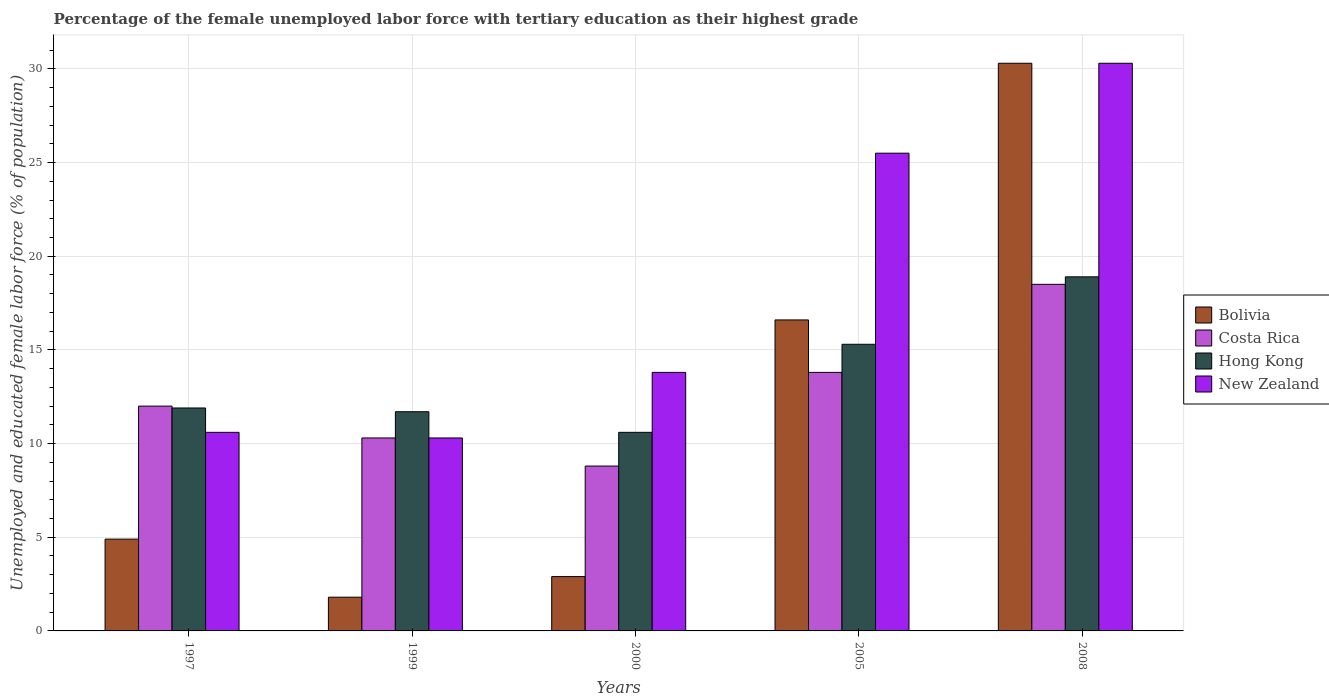How many different coloured bars are there?
Your answer should be very brief. 4. Are the number of bars on each tick of the X-axis equal?
Keep it short and to the point. Yes. How many bars are there on the 2nd tick from the left?
Your answer should be compact. 4. How many bars are there on the 2nd tick from the right?
Give a very brief answer. 4. In how many cases, is the number of bars for a given year not equal to the number of legend labels?
Offer a very short reply. 0. What is the percentage of the unemployed female labor force with tertiary education in New Zealand in 2000?
Your response must be concise. 13.8. Across all years, what is the maximum percentage of the unemployed female labor force with tertiary education in Costa Rica?
Your answer should be compact. 18.5. Across all years, what is the minimum percentage of the unemployed female labor force with tertiary education in Hong Kong?
Make the answer very short. 10.6. In which year was the percentage of the unemployed female labor force with tertiary education in New Zealand maximum?
Provide a short and direct response. 2008. In which year was the percentage of the unemployed female labor force with tertiary education in Bolivia minimum?
Give a very brief answer. 1999. What is the total percentage of the unemployed female labor force with tertiary education in Costa Rica in the graph?
Offer a very short reply. 63.4. What is the difference between the percentage of the unemployed female labor force with tertiary education in Hong Kong in 1999 and that in 2000?
Your answer should be compact. 1.1. What is the difference between the percentage of the unemployed female labor force with tertiary education in Bolivia in 2000 and the percentage of the unemployed female labor force with tertiary education in Hong Kong in 2005?
Ensure brevity in your answer.  -12.4. What is the average percentage of the unemployed female labor force with tertiary education in Costa Rica per year?
Your answer should be compact. 12.68. What is the ratio of the percentage of the unemployed female labor force with tertiary education in New Zealand in 1999 to that in 2008?
Offer a very short reply. 0.34. Is the percentage of the unemployed female labor force with tertiary education in Hong Kong in 1997 less than that in 2008?
Offer a very short reply. Yes. What is the difference between the highest and the second highest percentage of the unemployed female labor force with tertiary education in New Zealand?
Your response must be concise. 4.8. What is the difference between the highest and the lowest percentage of the unemployed female labor force with tertiary education in Hong Kong?
Offer a very short reply. 8.3. In how many years, is the percentage of the unemployed female labor force with tertiary education in Hong Kong greater than the average percentage of the unemployed female labor force with tertiary education in Hong Kong taken over all years?
Ensure brevity in your answer.  2. Is it the case that in every year, the sum of the percentage of the unemployed female labor force with tertiary education in Bolivia and percentage of the unemployed female labor force with tertiary education in Hong Kong is greater than the sum of percentage of the unemployed female labor force with tertiary education in Costa Rica and percentage of the unemployed female labor force with tertiary education in New Zealand?
Offer a very short reply. No. What does the 4th bar from the left in 2005 represents?
Offer a terse response. New Zealand. What does the 2nd bar from the right in 2005 represents?
Your answer should be compact. Hong Kong. Is it the case that in every year, the sum of the percentage of the unemployed female labor force with tertiary education in Costa Rica and percentage of the unemployed female labor force with tertiary education in Hong Kong is greater than the percentage of the unemployed female labor force with tertiary education in New Zealand?
Keep it short and to the point. Yes. Are all the bars in the graph horizontal?
Your answer should be compact. No. How many legend labels are there?
Give a very brief answer. 4. How are the legend labels stacked?
Offer a very short reply. Vertical. What is the title of the graph?
Offer a very short reply. Percentage of the female unemployed labor force with tertiary education as their highest grade. Does "Eritrea" appear as one of the legend labels in the graph?
Your answer should be very brief. No. What is the label or title of the X-axis?
Offer a terse response. Years. What is the label or title of the Y-axis?
Your answer should be compact. Unemployed and educated female labor force (% of population). What is the Unemployed and educated female labor force (% of population) in Bolivia in 1997?
Give a very brief answer. 4.9. What is the Unemployed and educated female labor force (% of population) in Hong Kong in 1997?
Your answer should be very brief. 11.9. What is the Unemployed and educated female labor force (% of population) of New Zealand in 1997?
Provide a short and direct response. 10.6. What is the Unemployed and educated female labor force (% of population) in Bolivia in 1999?
Keep it short and to the point. 1.8. What is the Unemployed and educated female labor force (% of population) in Costa Rica in 1999?
Offer a very short reply. 10.3. What is the Unemployed and educated female labor force (% of population) of Hong Kong in 1999?
Give a very brief answer. 11.7. What is the Unemployed and educated female labor force (% of population) of New Zealand in 1999?
Your answer should be very brief. 10.3. What is the Unemployed and educated female labor force (% of population) of Bolivia in 2000?
Make the answer very short. 2.9. What is the Unemployed and educated female labor force (% of population) in Costa Rica in 2000?
Ensure brevity in your answer.  8.8. What is the Unemployed and educated female labor force (% of population) of Hong Kong in 2000?
Provide a succinct answer. 10.6. What is the Unemployed and educated female labor force (% of population) of New Zealand in 2000?
Ensure brevity in your answer.  13.8. What is the Unemployed and educated female labor force (% of population) in Bolivia in 2005?
Give a very brief answer. 16.6. What is the Unemployed and educated female labor force (% of population) in Costa Rica in 2005?
Make the answer very short. 13.8. What is the Unemployed and educated female labor force (% of population) of Hong Kong in 2005?
Provide a succinct answer. 15.3. What is the Unemployed and educated female labor force (% of population) in New Zealand in 2005?
Provide a short and direct response. 25.5. What is the Unemployed and educated female labor force (% of population) in Bolivia in 2008?
Provide a short and direct response. 30.3. What is the Unemployed and educated female labor force (% of population) of Hong Kong in 2008?
Offer a terse response. 18.9. What is the Unemployed and educated female labor force (% of population) of New Zealand in 2008?
Make the answer very short. 30.3. Across all years, what is the maximum Unemployed and educated female labor force (% of population) in Bolivia?
Provide a short and direct response. 30.3. Across all years, what is the maximum Unemployed and educated female labor force (% of population) in Costa Rica?
Give a very brief answer. 18.5. Across all years, what is the maximum Unemployed and educated female labor force (% of population) in Hong Kong?
Make the answer very short. 18.9. Across all years, what is the maximum Unemployed and educated female labor force (% of population) of New Zealand?
Make the answer very short. 30.3. Across all years, what is the minimum Unemployed and educated female labor force (% of population) in Bolivia?
Provide a short and direct response. 1.8. Across all years, what is the minimum Unemployed and educated female labor force (% of population) of Costa Rica?
Provide a succinct answer. 8.8. Across all years, what is the minimum Unemployed and educated female labor force (% of population) of Hong Kong?
Give a very brief answer. 10.6. Across all years, what is the minimum Unemployed and educated female labor force (% of population) of New Zealand?
Provide a short and direct response. 10.3. What is the total Unemployed and educated female labor force (% of population) of Bolivia in the graph?
Make the answer very short. 56.5. What is the total Unemployed and educated female labor force (% of population) of Costa Rica in the graph?
Your response must be concise. 63.4. What is the total Unemployed and educated female labor force (% of population) in Hong Kong in the graph?
Your answer should be very brief. 68.4. What is the total Unemployed and educated female labor force (% of population) of New Zealand in the graph?
Offer a very short reply. 90.5. What is the difference between the Unemployed and educated female labor force (% of population) in Costa Rica in 1997 and that in 1999?
Make the answer very short. 1.7. What is the difference between the Unemployed and educated female labor force (% of population) in New Zealand in 1997 and that in 1999?
Keep it short and to the point. 0.3. What is the difference between the Unemployed and educated female labor force (% of population) of Bolivia in 1997 and that in 2000?
Your answer should be very brief. 2. What is the difference between the Unemployed and educated female labor force (% of population) of Costa Rica in 1997 and that in 2000?
Your response must be concise. 3.2. What is the difference between the Unemployed and educated female labor force (% of population) of New Zealand in 1997 and that in 2000?
Keep it short and to the point. -3.2. What is the difference between the Unemployed and educated female labor force (% of population) in New Zealand in 1997 and that in 2005?
Your response must be concise. -14.9. What is the difference between the Unemployed and educated female labor force (% of population) in Bolivia in 1997 and that in 2008?
Keep it short and to the point. -25.4. What is the difference between the Unemployed and educated female labor force (% of population) in Hong Kong in 1997 and that in 2008?
Offer a terse response. -7. What is the difference between the Unemployed and educated female labor force (% of population) in New Zealand in 1997 and that in 2008?
Your answer should be very brief. -19.7. What is the difference between the Unemployed and educated female labor force (% of population) of Bolivia in 1999 and that in 2000?
Offer a terse response. -1.1. What is the difference between the Unemployed and educated female labor force (% of population) in Costa Rica in 1999 and that in 2000?
Offer a very short reply. 1.5. What is the difference between the Unemployed and educated female labor force (% of population) in Hong Kong in 1999 and that in 2000?
Keep it short and to the point. 1.1. What is the difference between the Unemployed and educated female labor force (% of population) in New Zealand in 1999 and that in 2000?
Your answer should be compact. -3.5. What is the difference between the Unemployed and educated female labor force (% of population) of Bolivia in 1999 and that in 2005?
Your answer should be compact. -14.8. What is the difference between the Unemployed and educated female labor force (% of population) in Costa Rica in 1999 and that in 2005?
Offer a terse response. -3.5. What is the difference between the Unemployed and educated female labor force (% of population) in Hong Kong in 1999 and that in 2005?
Your answer should be very brief. -3.6. What is the difference between the Unemployed and educated female labor force (% of population) of New Zealand in 1999 and that in 2005?
Ensure brevity in your answer.  -15.2. What is the difference between the Unemployed and educated female labor force (% of population) in Bolivia in 1999 and that in 2008?
Provide a succinct answer. -28.5. What is the difference between the Unemployed and educated female labor force (% of population) of Costa Rica in 1999 and that in 2008?
Ensure brevity in your answer.  -8.2. What is the difference between the Unemployed and educated female labor force (% of population) in New Zealand in 1999 and that in 2008?
Offer a terse response. -20. What is the difference between the Unemployed and educated female labor force (% of population) of Bolivia in 2000 and that in 2005?
Give a very brief answer. -13.7. What is the difference between the Unemployed and educated female labor force (% of population) of Costa Rica in 2000 and that in 2005?
Provide a short and direct response. -5. What is the difference between the Unemployed and educated female labor force (% of population) in Bolivia in 2000 and that in 2008?
Your response must be concise. -27.4. What is the difference between the Unemployed and educated female labor force (% of population) of New Zealand in 2000 and that in 2008?
Give a very brief answer. -16.5. What is the difference between the Unemployed and educated female labor force (% of population) in Bolivia in 2005 and that in 2008?
Offer a very short reply. -13.7. What is the difference between the Unemployed and educated female labor force (% of population) in Bolivia in 1997 and the Unemployed and educated female labor force (% of population) in Costa Rica in 1999?
Offer a very short reply. -5.4. What is the difference between the Unemployed and educated female labor force (% of population) of Bolivia in 1997 and the Unemployed and educated female labor force (% of population) of Hong Kong in 1999?
Your answer should be very brief. -6.8. What is the difference between the Unemployed and educated female labor force (% of population) of Bolivia in 1997 and the Unemployed and educated female labor force (% of population) of New Zealand in 1999?
Offer a very short reply. -5.4. What is the difference between the Unemployed and educated female labor force (% of population) of Bolivia in 1997 and the Unemployed and educated female labor force (% of population) of New Zealand in 2000?
Offer a very short reply. -8.9. What is the difference between the Unemployed and educated female labor force (% of population) of Costa Rica in 1997 and the Unemployed and educated female labor force (% of population) of Hong Kong in 2000?
Offer a terse response. 1.4. What is the difference between the Unemployed and educated female labor force (% of population) of Hong Kong in 1997 and the Unemployed and educated female labor force (% of population) of New Zealand in 2000?
Ensure brevity in your answer.  -1.9. What is the difference between the Unemployed and educated female labor force (% of population) of Bolivia in 1997 and the Unemployed and educated female labor force (% of population) of Costa Rica in 2005?
Make the answer very short. -8.9. What is the difference between the Unemployed and educated female labor force (% of population) of Bolivia in 1997 and the Unemployed and educated female labor force (% of population) of Hong Kong in 2005?
Offer a terse response. -10.4. What is the difference between the Unemployed and educated female labor force (% of population) of Bolivia in 1997 and the Unemployed and educated female labor force (% of population) of New Zealand in 2005?
Give a very brief answer. -20.6. What is the difference between the Unemployed and educated female labor force (% of population) in Hong Kong in 1997 and the Unemployed and educated female labor force (% of population) in New Zealand in 2005?
Offer a very short reply. -13.6. What is the difference between the Unemployed and educated female labor force (% of population) of Bolivia in 1997 and the Unemployed and educated female labor force (% of population) of New Zealand in 2008?
Provide a succinct answer. -25.4. What is the difference between the Unemployed and educated female labor force (% of population) of Costa Rica in 1997 and the Unemployed and educated female labor force (% of population) of Hong Kong in 2008?
Offer a terse response. -6.9. What is the difference between the Unemployed and educated female labor force (% of population) of Costa Rica in 1997 and the Unemployed and educated female labor force (% of population) of New Zealand in 2008?
Provide a succinct answer. -18.3. What is the difference between the Unemployed and educated female labor force (% of population) in Hong Kong in 1997 and the Unemployed and educated female labor force (% of population) in New Zealand in 2008?
Your answer should be very brief. -18.4. What is the difference between the Unemployed and educated female labor force (% of population) in Bolivia in 1999 and the Unemployed and educated female labor force (% of population) in Costa Rica in 2000?
Offer a very short reply. -7. What is the difference between the Unemployed and educated female labor force (% of population) of Bolivia in 1999 and the Unemployed and educated female labor force (% of population) of Hong Kong in 2000?
Your answer should be compact. -8.8. What is the difference between the Unemployed and educated female labor force (% of population) of Costa Rica in 1999 and the Unemployed and educated female labor force (% of population) of Hong Kong in 2000?
Keep it short and to the point. -0.3. What is the difference between the Unemployed and educated female labor force (% of population) of Costa Rica in 1999 and the Unemployed and educated female labor force (% of population) of New Zealand in 2000?
Your answer should be very brief. -3.5. What is the difference between the Unemployed and educated female labor force (% of population) in Bolivia in 1999 and the Unemployed and educated female labor force (% of population) in Hong Kong in 2005?
Give a very brief answer. -13.5. What is the difference between the Unemployed and educated female labor force (% of population) of Bolivia in 1999 and the Unemployed and educated female labor force (% of population) of New Zealand in 2005?
Provide a short and direct response. -23.7. What is the difference between the Unemployed and educated female labor force (% of population) in Costa Rica in 1999 and the Unemployed and educated female labor force (% of population) in Hong Kong in 2005?
Your answer should be very brief. -5. What is the difference between the Unemployed and educated female labor force (% of population) in Costa Rica in 1999 and the Unemployed and educated female labor force (% of population) in New Zealand in 2005?
Provide a succinct answer. -15.2. What is the difference between the Unemployed and educated female labor force (% of population) of Bolivia in 1999 and the Unemployed and educated female labor force (% of population) of Costa Rica in 2008?
Make the answer very short. -16.7. What is the difference between the Unemployed and educated female labor force (% of population) in Bolivia in 1999 and the Unemployed and educated female labor force (% of population) in Hong Kong in 2008?
Your answer should be very brief. -17.1. What is the difference between the Unemployed and educated female labor force (% of population) of Bolivia in 1999 and the Unemployed and educated female labor force (% of population) of New Zealand in 2008?
Your answer should be compact. -28.5. What is the difference between the Unemployed and educated female labor force (% of population) in Costa Rica in 1999 and the Unemployed and educated female labor force (% of population) in Hong Kong in 2008?
Your answer should be compact. -8.6. What is the difference between the Unemployed and educated female labor force (% of population) in Hong Kong in 1999 and the Unemployed and educated female labor force (% of population) in New Zealand in 2008?
Your answer should be very brief. -18.6. What is the difference between the Unemployed and educated female labor force (% of population) in Bolivia in 2000 and the Unemployed and educated female labor force (% of population) in Costa Rica in 2005?
Offer a very short reply. -10.9. What is the difference between the Unemployed and educated female labor force (% of population) in Bolivia in 2000 and the Unemployed and educated female labor force (% of population) in Hong Kong in 2005?
Your answer should be compact. -12.4. What is the difference between the Unemployed and educated female labor force (% of population) in Bolivia in 2000 and the Unemployed and educated female labor force (% of population) in New Zealand in 2005?
Give a very brief answer. -22.6. What is the difference between the Unemployed and educated female labor force (% of population) of Costa Rica in 2000 and the Unemployed and educated female labor force (% of population) of New Zealand in 2005?
Your answer should be very brief. -16.7. What is the difference between the Unemployed and educated female labor force (% of population) in Hong Kong in 2000 and the Unemployed and educated female labor force (% of population) in New Zealand in 2005?
Your response must be concise. -14.9. What is the difference between the Unemployed and educated female labor force (% of population) in Bolivia in 2000 and the Unemployed and educated female labor force (% of population) in Costa Rica in 2008?
Offer a very short reply. -15.6. What is the difference between the Unemployed and educated female labor force (% of population) in Bolivia in 2000 and the Unemployed and educated female labor force (% of population) in New Zealand in 2008?
Provide a succinct answer. -27.4. What is the difference between the Unemployed and educated female labor force (% of population) of Costa Rica in 2000 and the Unemployed and educated female labor force (% of population) of Hong Kong in 2008?
Give a very brief answer. -10.1. What is the difference between the Unemployed and educated female labor force (% of population) of Costa Rica in 2000 and the Unemployed and educated female labor force (% of population) of New Zealand in 2008?
Your answer should be very brief. -21.5. What is the difference between the Unemployed and educated female labor force (% of population) in Hong Kong in 2000 and the Unemployed and educated female labor force (% of population) in New Zealand in 2008?
Offer a terse response. -19.7. What is the difference between the Unemployed and educated female labor force (% of population) in Bolivia in 2005 and the Unemployed and educated female labor force (% of population) in Costa Rica in 2008?
Give a very brief answer. -1.9. What is the difference between the Unemployed and educated female labor force (% of population) in Bolivia in 2005 and the Unemployed and educated female labor force (% of population) in New Zealand in 2008?
Your answer should be very brief. -13.7. What is the difference between the Unemployed and educated female labor force (% of population) of Costa Rica in 2005 and the Unemployed and educated female labor force (% of population) of Hong Kong in 2008?
Offer a very short reply. -5.1. What is the difference between the Unemployed and educated female labor force (% of population) in Costa Rica in 2005 and the Unemployed and educated female labor force (% of population) in New Zealand in 2008?
Provide a succinct answer. -16.5. What is the difference between the Unemployed and educated female labor force (% of population) of Hong Kong in 2005 and the Unemployed and educated female labor force (% of population) of New Zealand in 2008?
Make the answer very short. -15. What is the average Unemployed and educated female labor force (% of population) of Bolivia per year?
Offer a terse response. 11.3. What is the average Unemployed and educated female labor force (% of population) of Costa Rica per year?
Your answer should be very brief. 12.68. What is the average Unemployed and educated female labor force (% of population) of Hong Kong per year?
Keep it short and to the point. 13.68. What is the average Unemployed and educated female labor force (% of population) in New Zealand per year?
Provide a short and direct response. 18.1. In the year 1997, what is the difference between the Unemployed and educated female labor force (% of population) of Bolivia and Unemployed and educated female labor force (% of population) of Hong Kong?
Your answer should be compact. -7. In the year 1997, what is the difference between the Unemployed and educated female labor force (% of population) in Bolivia and Unemployed and educated female labor force (% of population) in New Zealand?
Provide a short and direct response. -5.7. In the year 1999, what is the difference between the Unemployed and educated female labor force (% of population) of Bolivia and Unemployed and educated female labor force (% of population) of Costa Rica?
Ensure brevity in your answer.  -8.5. In the year 1999, what is the difference between the Unemployed and educated female labor force (% of population) in Hong Kong and Unemployed and educated female labor force (% of population) in New Zealand?
Make the answer very short. 1.4. In the year 2000, what is the difference between the Unemployed and educated female labor force (% of population) of Bolivia and Unemployed and educated female labor force (% of population) of Costa Rica?
Keep it short and to the point. -5.9. In the year 2000, what is the difference between the Unemployed and educated female labor force (% of population) in Bolivia and Unemployed and educated female labor force (% of population) in New Zealand?
Provide a succinct answer. -10.9. In the year 2000, what is the difference between the Unemployed and educated female labor force (% of population) in Costa Rica and Unemployed and educated female labor force (% of population) in Hong Kong?
Your answer should be compact. -1.8. In the year 2000, what is the difference between the Unemployed and educated female labor force (% of population) in Costa Rica and Unemployed and educated female labor force (% of population) in New Zealand?
Your response must be concise. -5. In the year 2000, what is the difference between the Unemployed and educated female labor force (% of population) in Hong Kong and Unemployed and educated female labor force (% of population) in New Zealand?
Provide a succinct answer. -3.2. In the year 2005, what is the difference between the Unemployed and educated female labor force (% of population) in Bolivia and Unemployed and educated female labor force (% of population) in New Zealand?
Make the answer very short. -8.9. In the year 2005, what is the difference between the Unemployed and educated female labor force (% of population) of Costa Rica and Unemployed and educated female labor force (% of population) of New Zealand?
Your response must be concise. -11.7. In the year 2008, what is the difference between the Unemployed and educated female labor force (% of population) in Bolivia and Unemployed and educated female labor force (% of population) in Hong Kong?
Make the answer very short. 11.4. In the year 2008, what is the difference between the Unemployed and educated female labor force (% of population) of Bolivia and Unemployed and educated female labor force (% of population) of New Zealand?
Offer a terse response. 0. In the year 2008, what is the difference between the Unemployed and educated female labor force (% of population) of Costa Rica and Unemployed and educated female labor force (% of population) of Hong Kong?
Your answer should be very brief. -0.4. In the year 2008, what is the difference between the Unemployed and educated female labor force (% of population) in Hong Kong and Unemployed and educated female labor force (% of population) in New Zealand?
Provide a short and direct response. -11.4. What is the ratio of the Unemployed and educated female labor force (% of population) of Bolivia in 1997 to that in 1999?
Ensure brevity in your answer.  2.72. What is the ratio of the Unemployed and educated female labor force (% of population) of Costa Rica in 1997 to that in 1999?
Provide a succinct answer. 1.17. What is the ratio of the Unemployed and educated female labor force (% of population) in Hong Kong in 1997 to that in 1999?
Offer a very short reply. 1.02. What is the ratio of the Unemployed and educated female labor force (% of population) of New Zealand in 1997 to that in 1999?
Ensure brevity in your answer.  1.03. What is the ratio of the Unemployed and educated female labor force (% of population) of Bolivia in 1997 to that in 2000?
Make the answer very short. 1.69. What is the ratio of the Unemployed and educated female labor force (% of population) in Costa Rica in 1997 to that in 2000?
Offer a very short reply. 1.36. What is the ratio of the Unemployed and educated female labor force (% of population) in Hong Kong in 1997 to that in 2000?
Your response must be concise. 1.12. What is the ratio of the Unemployed and educated female labor force (% of population) of New Zealand in 1997 to that in 2000?
Make the answer very short. 0.77. What is the ratio of the Unemployed and educated female labor force (% of population) of Bolivia in 1997 to that in 2005?
Provide a succinct answer. 0.3. What is the ratio of the Unemployed and educated female labor force (% of population) in Costa Rica in 1997 to that in 2005?
Your response must be concise. 0.87. What is the ratio of the Unemployed and educated female labor force (% of population) in Hong Kong in 1997 to that in 2005?
Make the answer very short. 0.78. What is the ratio of the Unemployed and educated female labor force (% of population) in New Zealand in 1997 to that in 2005?
Give a very brief answer. 0.42. What is the ratio of the Unemployed and educated female labor force (% of population) in Bolivia in 1997 to that in 2008?
Your answer should be very brief. 0.16. What is the ratio of the Unemployed and educated female labor force (% of population) of Costa Rica in 1997 to that in 2008?
Ensure brevity in your answer.  0.65. What is the ratio of the Unemployed and educated female labor force (% of population) of Hong Kong in 1997 to that in 2008?
Offer a terse response. 0.63. What is the ratio of the Unemployed and educated female labor force (% of population) of New Zealand in 1997 to that in 2008?
Offer a terse response. 0.35. What is the ratio of the Unemployed and educated female labor force (% of population) in Bolivia in 1999 to that in 2000?
Your response must be concise. 0.62. What is the ratio of the Unemployed and educated female labor force (% of population) in Costa Rica in 1999 to that in 2000?
Ensure brevity in your answer.  1.17. What is the ratio of the Unemployed and educated female labor force (% of population) of Hong Kong in 1999 to that in 2000?
Ensure brevity in your answer.  1.1. What is the ratio of the Unemployed and educated female labor force (% of population) in New Zealand in 1999 to that in 2000?
Make the answer very short. 0.75. What is the ratio of the Unemployed and educated female labor force (% of population) in Bolivia in 1999 to that in 2005?
Your answer should be compact. 0.11. What is the ratio of the Unemployed and educated female labor force (% of population) in Costa Rica in 1999 to that in 2005?
Ensure brevity in your answer.  0.75. What is the ratio of the Unemployed and educated female labor force (% of population) of Hong Kong in 1999 to that in 2005?
Provide a short and direct response. 0.76. What is the ratio of the Unemployed and educated female labor force (% of population) in New Zealand in 1999 to that in 2005?
Give a very brief answer. 0.4. What is the ratio of the Unemployed and educated female labor force (% of population) in Bolivia in 1999 to that in 2008?
Ensure brevity in your answer.  0.06. What is the ratio of the Unemployed and educated female labor force (% of population) of Costa Rica in 1999 to that in 2008?
Provide a succinct answer. 0.56. What is the ratio of the Unemployed and educated female labor force (% of population) of Hong Kong in 1999 to that in 2008?
Offer a terse response. 0.62. What is the ratio of the Unemployed and educated female labor force (% of population) in New Zealand in 1999 to that in 2008?
Provide a short and direct response. 0.34. What is the ratio of the Unemployed and educated female labor force (% of population) in Bolivia in 2000 to that in 2005?
Offer a very short reply. 0.17. What is the ratio of the Unemployed and educated female labor force (% of population) of Costa Rica in 2000 to that in 2005?
Your response must be concise. 0.64. What is the ratio of the Unemployed and educated female labor force (% of population) in Hong Kong in 2000 to that in 2005?
Offer a very short reply. 0.69. What is the ratio of the Unemployed and educated female labor force (% of population) in New Zealand in 2000 to that in 2005?
Give a very brief answer. 0.54. What is the ratio of the Unemployed and educated female labor force (% of population) of Bolivia in 2000 to that in 2008?
Provide a succinct answer. 0.1. What is the ratio of the Unemployed and educated female labor force (% of population) in Costa Rica in 2000 to that in 2008?
Your response must be concise. 0.48. What is the ratio of the Unemployed and educated female labor force (% of population) of Hong Kong in 2000 to that in 2008?
Provide a succinct answer. 0.56. What is the ratio of the Unemployed and educated female labor force (% of population) in New Zealand in 2000 to that in 2008?
Offer a terse response. 0.46. What is the ratio of the Unemployed and educated female labor force (% of population) of Bolivia in 2005 to that in 2008?
Your answer should be very brief. 0.55. What is the ratio of the Unemployed and educated female labor force (% of population) in Costa Rica in 2005 to that in 2008?
Provide a succinct answer. 0.75. What is the ratio of the Unemployed and educated female labor force (% of population) in Hong Kong in 2005 to that in 2008?
Keep it short and to the point. 0.81. What is the ratio of the Unemployed and educated female labor force (% of population) of New Zealand in 2005 to that in 2008?
Give a very brief answer. 0.84. What is the difference between the highest and the second highest Unemployed and educated female labor force (% of population) in Bolivia?
Provide a short and direct response. 13.7. What is the difference between the highest and the second highest Unemployed and educated female labor force (% of population) in Costa Rica?
Provide a succinct answer. 4.7. What is the difference between the highest and the second highest Unemployed and educated female labor force (% of population) in Hong Kong?
Give a very brief answer. 3.6. What is the difference between the highest and the lowest Unemployed and educated female labor force (% of population) in Hong Kong?
Provide a short and direct response. 8.3. 